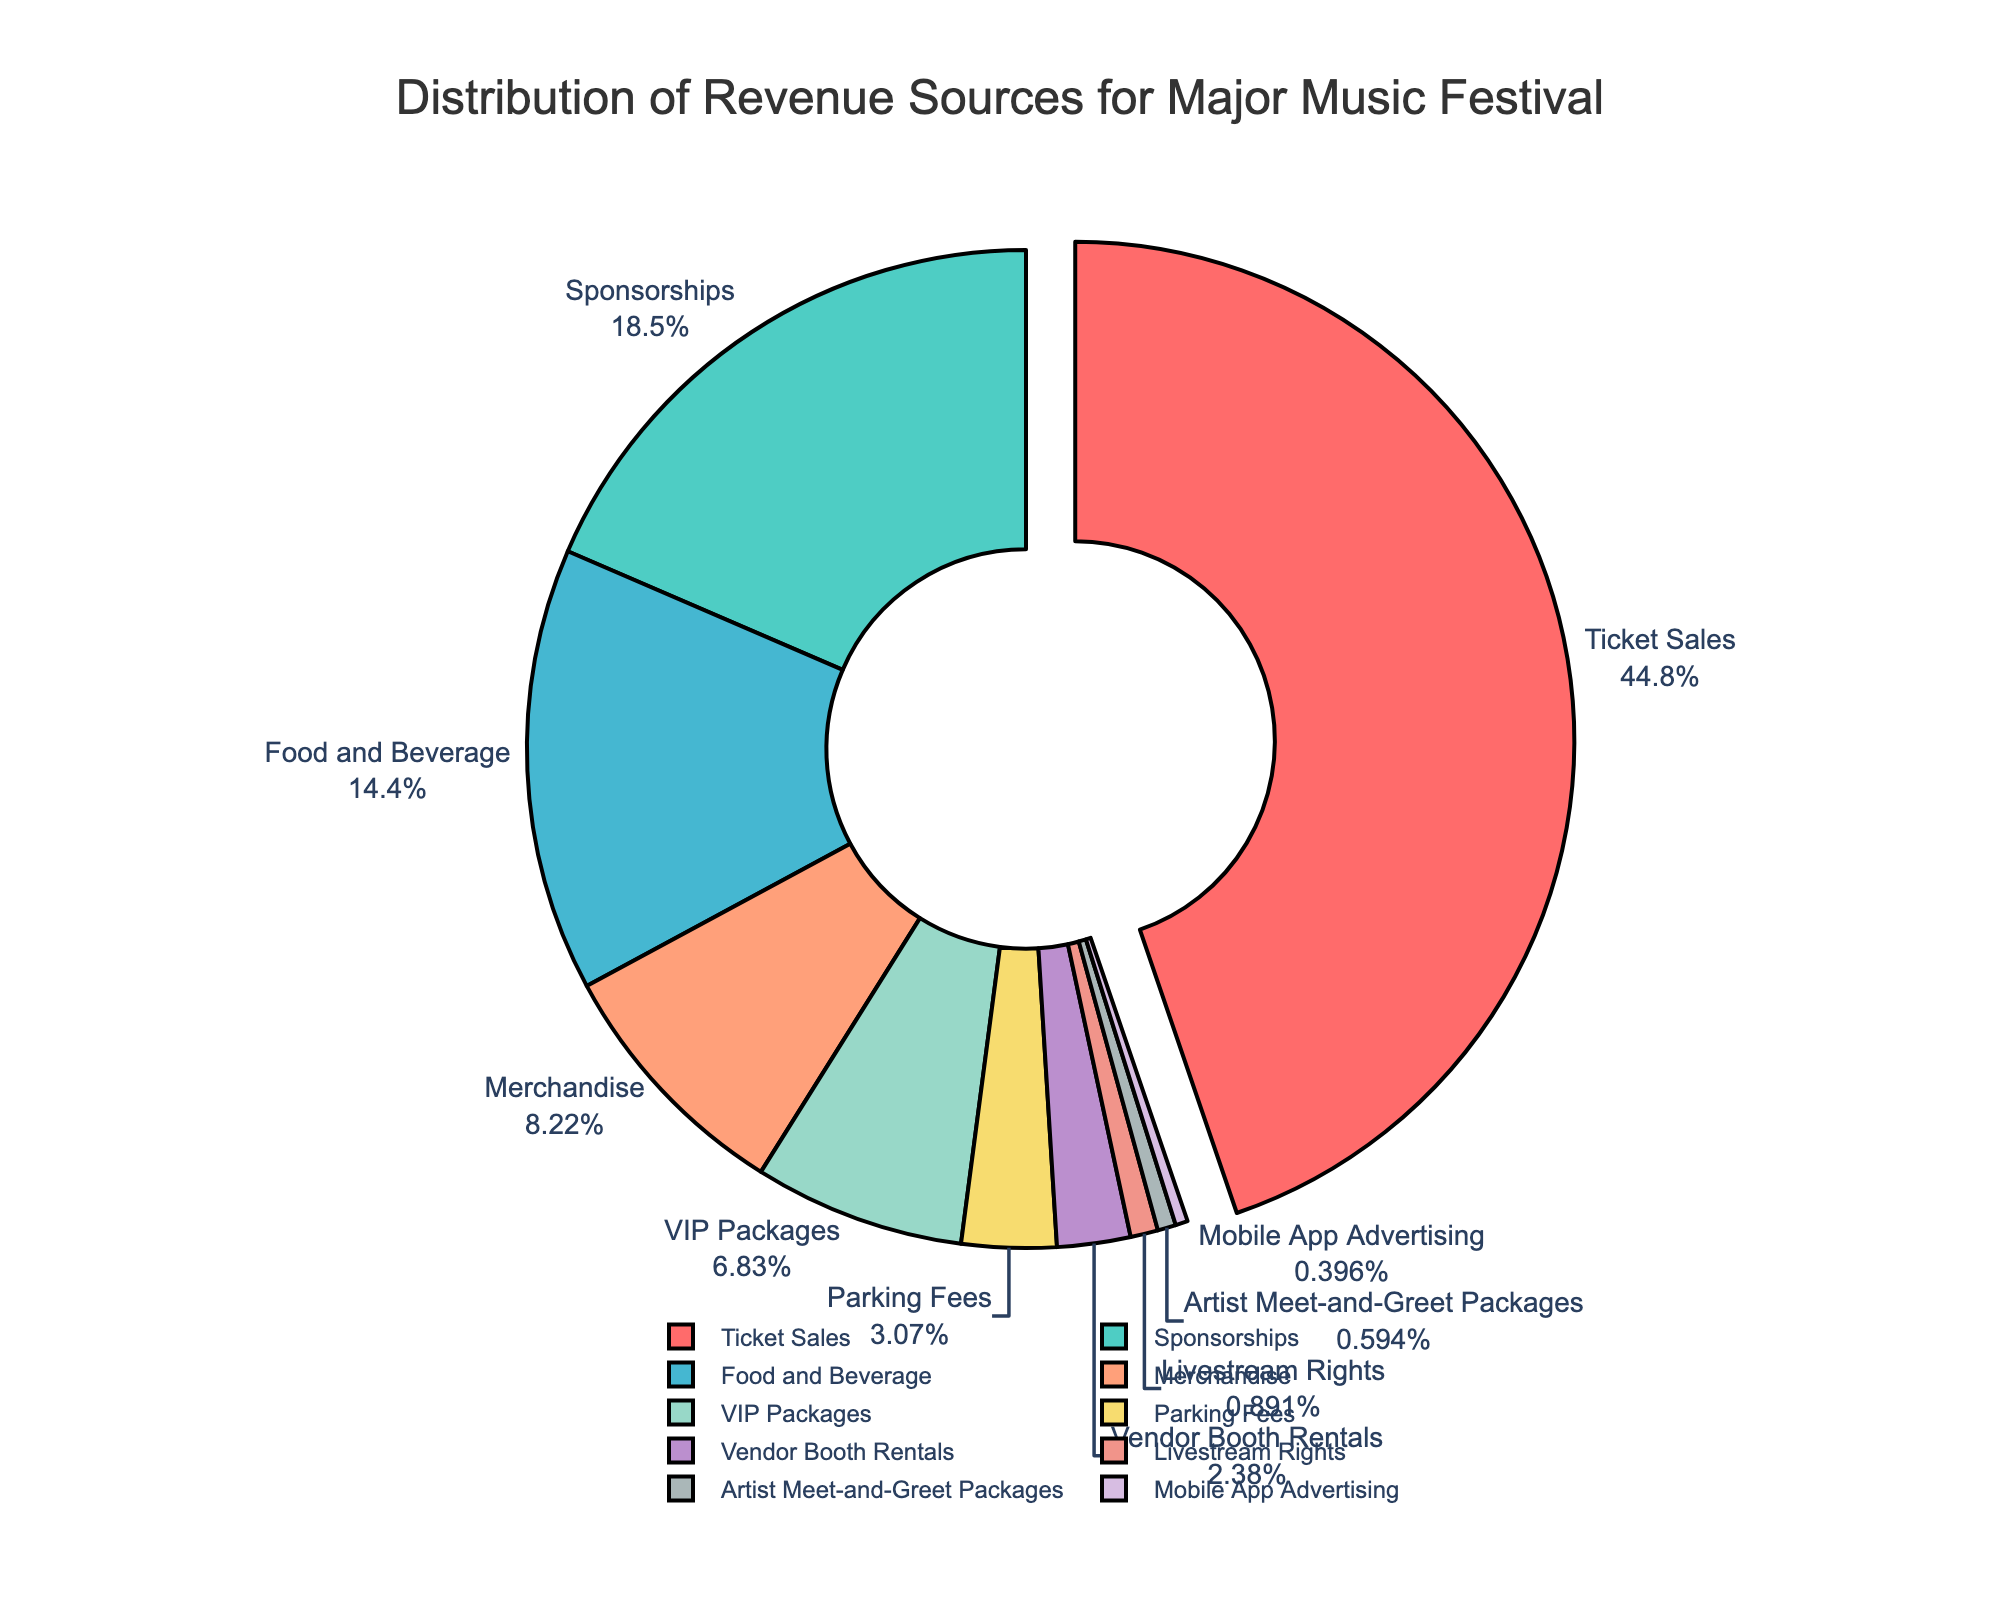What percentage of total revenue comes from Ticket Sales, Sponsorships, and Merchandise combined? First, identify the percentages of Ticket Sales (45.2), Sponsorships (18.7), and Merchandise (8.3). Then sum these values: 45.2 + 18.7 + 8.3 = 72.2
Answer: 72.2 Which revenue source contributes more to the total revenue, Food and Beverage or VIP Packages? Compare the percentages: Food and Beverage is 14.5% and VIP Packages is 6.9%. 14.5 is greater than 6.9
Answer: Food and Beverage How many sources contribute less than 2% to the total revenue? List them. Identify and count the sources with percentages less than 2%: Livestream Rights (0.9%), Artist Meet-and-Greet Packages (0.6%), and Mobile App Advertising (0.4%). There are 3 such sources: Livestream Rights, Artist Meet-and-Greet Packages, and Mobile App Advertising
Answer: 3: Livestream Rights, Artist Meet-and-Greet Packages, and Mobile App Advertising Which color represents the revenue from Vendor Booth Rentals? Locate the slice labeled "Vendor Booth Rentals" and identify its color: the color is light violet.
Answer: light violet Is the contribution of Parking Fees greater than that of Vendor Booth Rentals? Compare the percentages: Parking Fees is 3.1% and Vendor Booth Rentals is 2.4%. 3.1 is greater than 2.4
Answer: Yes What is the difference in percentage between the highest and lowest revenue sources? Identify the highest percentage (Ticket Sales, 45.2%) and the lowest percentage (Mobile App Advertising, 0.4%). Subtract the lowest from the highest: 45.2 - 0.4 = 44.8
Answer: 44.8 Which sources contribute between 5% and 10% of the total revenue? Identify the sources with percentages within the range 5% to 10%: Merchandise (8.3%) and VIP Packages (6.9%)
Answer: Merchandise and VIP Packages How much more does Sponsorships contribute than Food and Beverage? Find the percentages: Sponsorships (18.7%) and Food and Beverage (14.5%). Subtract the smaller from the larger: 18.7 - 14.5 = 4.2
Answer: 4.2 What slice is being pulled out of the pie chart? The pulled-out slice represents Ticket Sales, which is highlighted by being separated from the rest of the pie.
Answer: Ticket Sales 